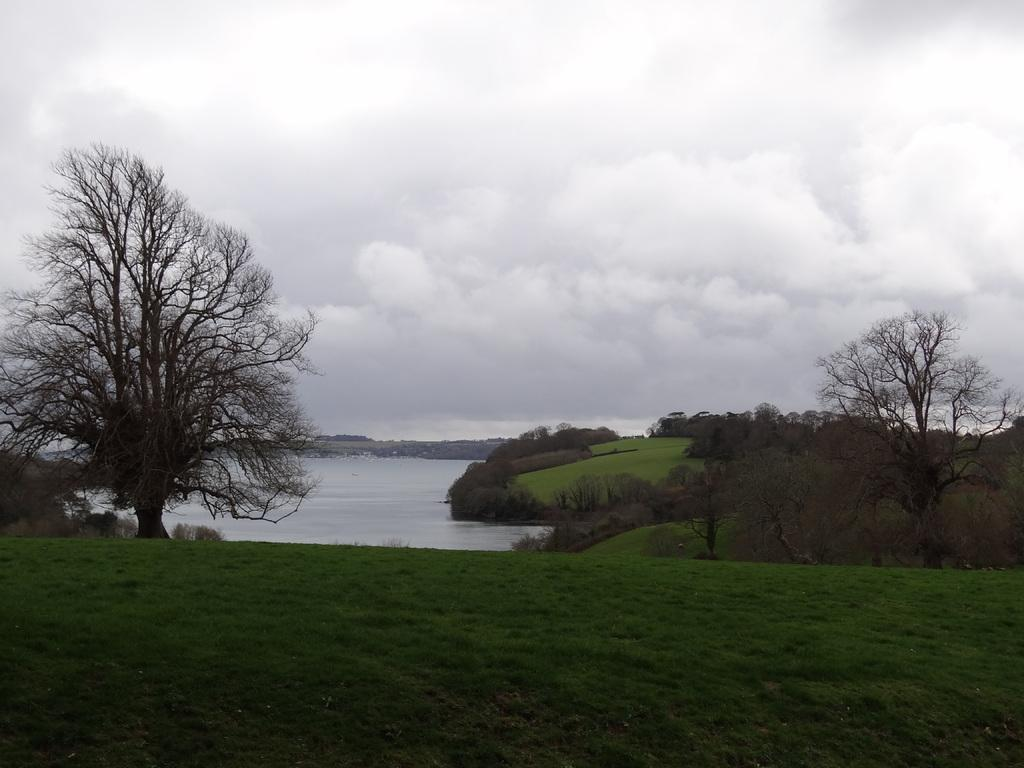What type of vegetation can be seen in the image? There are trees in the image. What else can be seen on the ground in the image? There is grass in the image. What is visible in the water in the image? The water is visible in the image, but it is not clear what is inside it. What is visible in the sky in the image? The sky is visible in the image, and there are clouds in it. Where is the lettuce growing in the image? There is no lettuce present in the image. What type of scale can be seen in the image? There is no scale present in the image. 